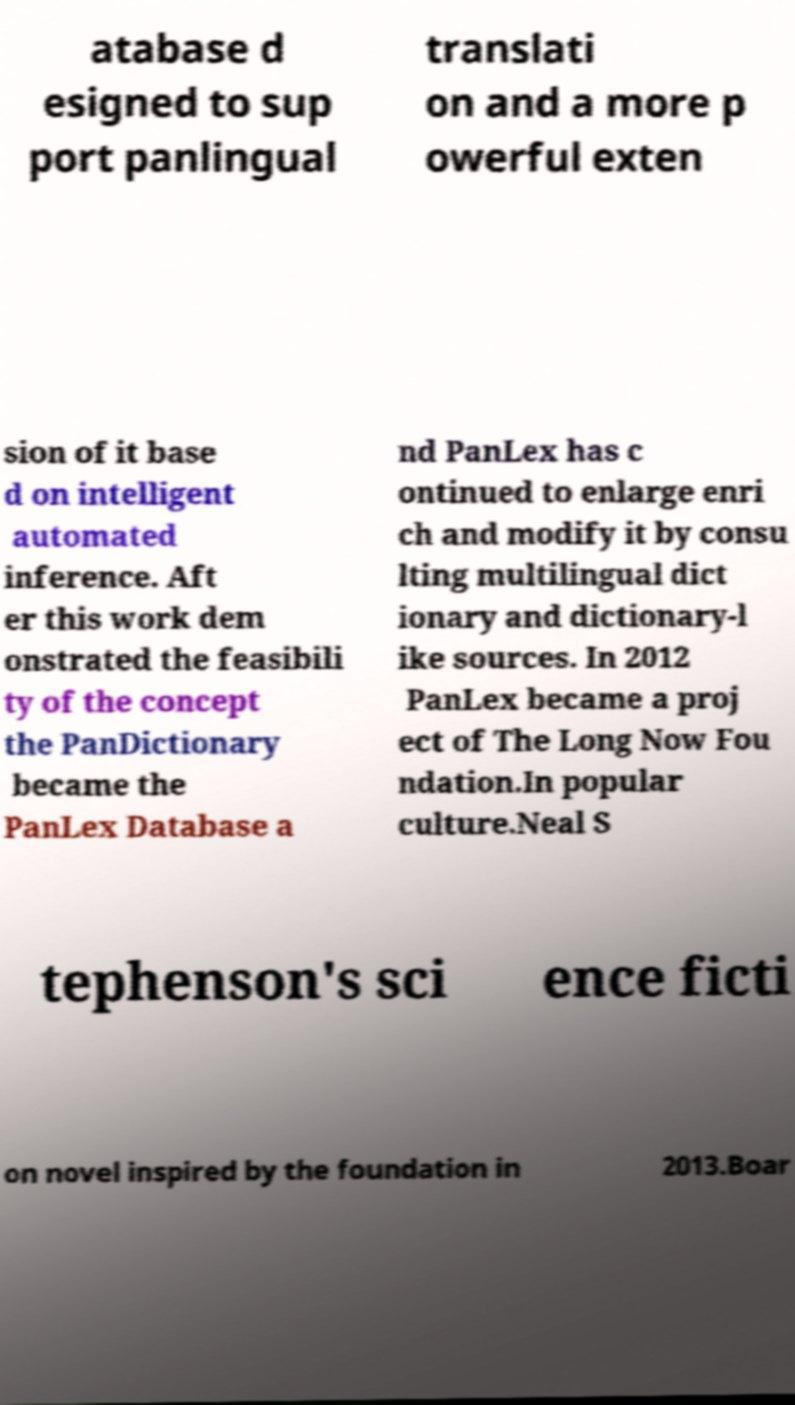Can you accurately transcribe the text from the provided image for me? atabase d esigned to sup port panlingual translati on and a more p owerful exten sion of it base d on intelligent automated inference. Aft er this work dem onstrated the feasibili ty of the concept the PanDictionary became the PanLex Database a nd PanLex has c ontinued to enlarge enri ch and modify it by consu lting multilingual dict ionary and dictionary-l ike sources. In 2012 PanLex became a proj ect of The Long Now Fou ndation.In popular culture.Neal S tephenson's sci ence ficti on novel inspired by the foundation in 2013.Boar 